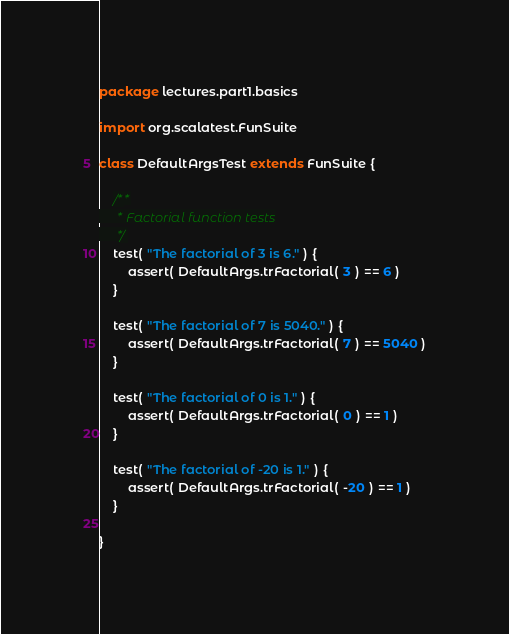<code> <loc_0><loc_0><loc_500><loc_500><_Scala_>package lectures.part1.basics

import org.scalatest.FunSuite

class DefaultArgsTest extends FunSuite {
	
	/**
	 * Factorial function tests
	 */
	test( "The factorial of 3 is 6." ) {
		assert( DefaultArgs.trFactorial( 3 ) == 6 )
	}
	
	test( "The factorial of 7 is 5040." ) {
		assert( DefaultArgs.trFactorial( 7 ) == 5040 )
	}
	
	test( "The factorial of 0 is 1." ) {
		assert( DefaultArgs.trFactorial( 0 ) == 1 )
	}
	
	test( "The factorial of -20 is 1." ) {
		assert( DefaultArgs.trFactorial( -20 ) == 1 )
	}
	
}
</code> 